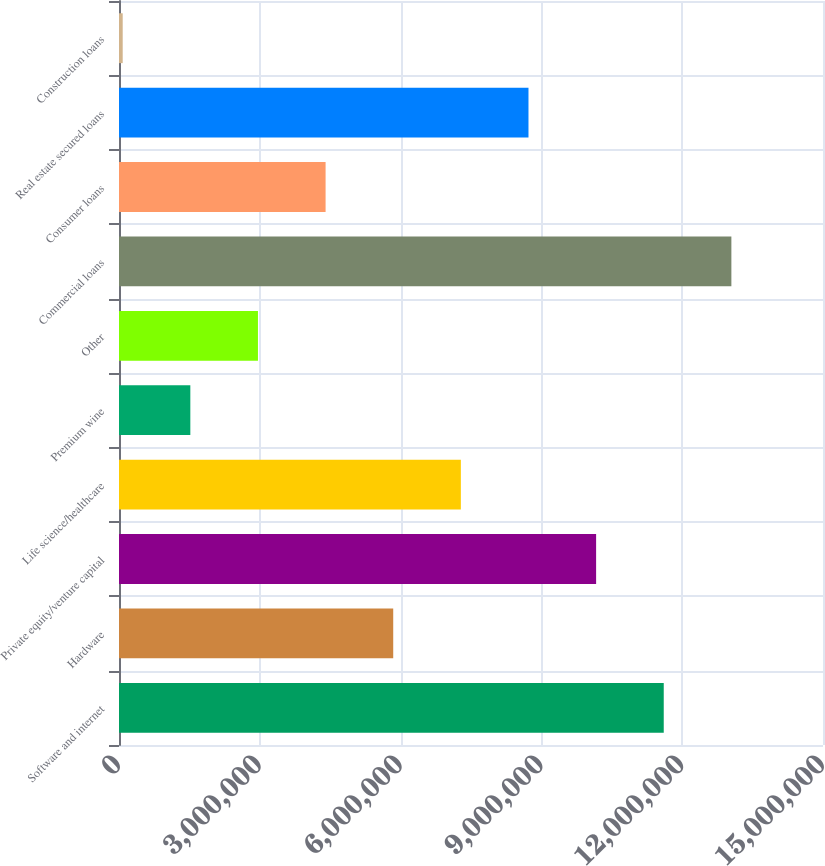<chart> <loc_0><loc_0><loc_500><loc_500><bar_chart><fcel>Software and internet<fcel>Hardware<fcel>Private equity/venture capital<fcel>Life science/healthcare<fcel>Premium wine<fcel>Other<fcel>Commercial loans<fcel>Consumer loans<fcel>Real estate secured loans<fcel>Construction loans<nl><fcel>1.16068e+07<fcel>5.84282e+06<fcel>1.01658e+07<fcel>7.28381e+06<fcel>1.51984e+06<fcel>2.96083e+06<fcel>1.30478e+07<fcel>4.40183e+06<fcel>8.7248e+06<fcel>78851<nl></chart> 